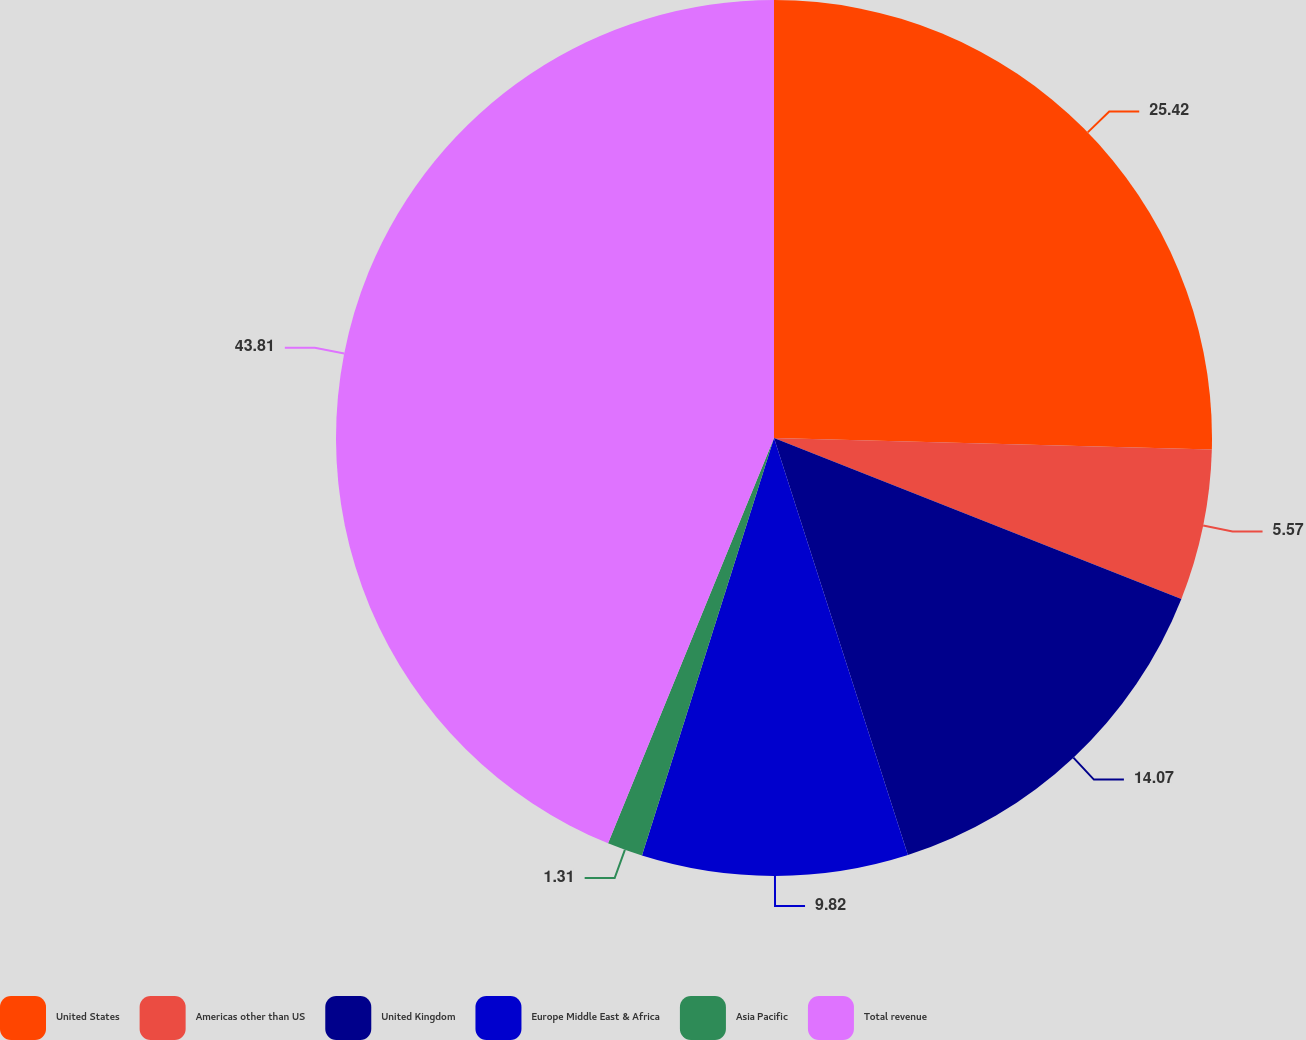Convert chart. <chart><loc_0><loc_0><loc_500><loc_500><pie_chart><fcel>United States<fcel>Americas other than US<fcel>United Kingdom<fcel>Europe Middle East & Africa<fcel>Asia Pacific<fcel>Total revenue<nl><fcel>25.42%<fcel>5.57%<fcel>14.07%<fcel>9.82%<fcel>1.31%<fcel>43.82%<nl></chart> 